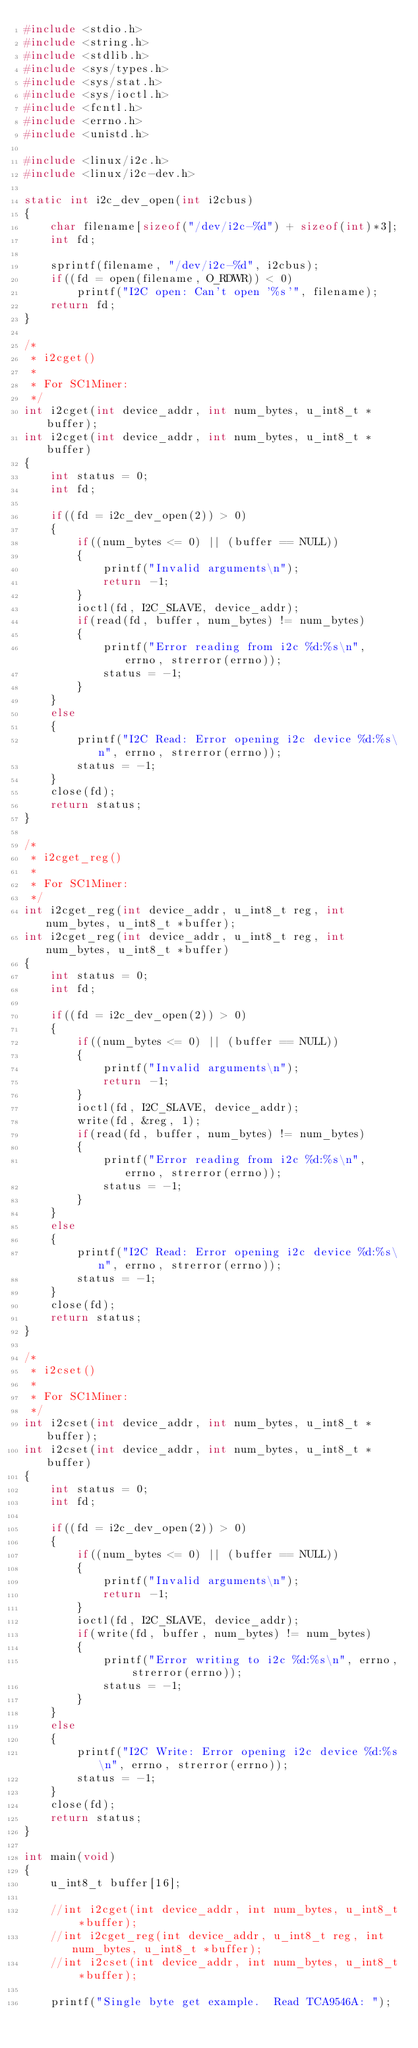Convert code to text. <code><loc_0><loc_0><loc_500><loc_500><_C_>#include <stdio.h>
#include <string.h>
#include <stdlib.h>
#include <sys/types.h>
#include <sys/stat.h>
#include <sys/ioctl.h>
#include <fcntl.h>
#include <errno.h>
#include <unistd.h>

#include <linux/i2c.h>
#include <linux/i2c-dev.h>

static int i2c_dev_open(int i2cbus)
{
    char filename[sizeof("/dev/i2c-%d") + sizeof(int)*3];
    int fd;

    sprintf(filename, "/dev/i2c-%d", i2cbus);
    if((fd = open(filename, O_RDWR)) < 0)
        printf("I2C open: Can't open '%s'", filename);
    return fd;
}

/*
 * i2cget()
 *
 * For SC1Miner:
 */
int i2cget(int device_addr, int num_bytes, u_int8_t *buffer);
int i2cget(int device_addr, int num_bytes, u_int8_t *buffer)
{
    int status = 0;
    int fd;

    if((fd = i2c_dev_open(2)) > 0)
    {
        if((num_bytes <= 0) || (buffer == NULL))
        {
            printf("Invalid arguments\n");
            return -1;
        }
        ioctl(fd, I2C_SLAVE, device_addr);
        if(read(fd, buffer, num_bytes) != num_bytes)
        {
            printf("Error reading from i2c %d:%s\n", errno, strerror(errno));
            status = -1;
        }
    }
    else
    {
        printf("I2C Read: Error opening i2c device %d:%s\n", errno, strerror(errno));
        status = -1;
    }
    close(fd);
    return status;
}

/*
 * i2cget_reg()
 *
 * For SC1Miner:
 */
int i2cget_reg(int device_addr, u_int8_t reg, int num_bytes, u_int8_t *buffer);
int i2cget_reg(int device_addr, u_int8_t reg, int num_bytes, u_int8_t *buffer)
{
    int status = 0;
    int fd;

    if((fd = i2c_dev_open(2)) > 0)
    {
        if((num_bytes <= 0) || (buffer == NULL))
        {
            printf("Invalid arguments\n");
            return -1;
        }
        ioctl(fd, I2C_SLAVE, device_addr);
        write(fd, &reg, 1);
        if(read(fd, buffer, num_bytes) != num_bytes)
        {
            printf("Error reading from i2c %d:%s\n", errno, strerror(errno));
            status = -1;
        }
    }
    else
    {
        printf("I2C Read: Error opening i2c device %d:%s\n", errno, strerror(errno));
        status = -1;
    }
    close(fd);
    return status;
}

/*
 * i2cset()
 *
 * For SC1Miner:
 */
int i2cset(int device_addr, int num_bytes, u_int8_t *buffer);
int i2cset(int device_addr, int num_bytes, u_int8_t *buffer)
{
    int status = 0;
    int fd;

    if((fd = i2c_dev_open(2)) > 0)
    {
        if((num_bytes <= 0) || (buffer == NULL))
        {
            printf("Invalid arguments\n");
            return -1;
        }
        ioctl(fd, I2C_SLAVE, device_addr);
        if(write(fd, buffer, num_bytes) != num_bytes)
        {
            printf("Error writing to i2c %d:%s\n", errno, strerror(errno));
            status = -1;
        }
    }
    else
    {
        printf("I2C Write: Error opening i2c device %d:%s\n", errno, strerror(errno));
        status = -1;
    }
    close(fd);
    return status;
}

int main(void)
{
    u_int8_t buffer[16];
    
    //int i2cget(int device_addr, int num_bytes, u_int8_t *buffer);
    //int i2cget_reg(int device_addr, u_int8_t reg, int num_bytes, u_int8_t *buffer);
    //int i2cset(int device_addr, int num_bytes, u_int8_t *buffer);

    printf("Single byte get example.  Read TCA9546A: ");</code> 